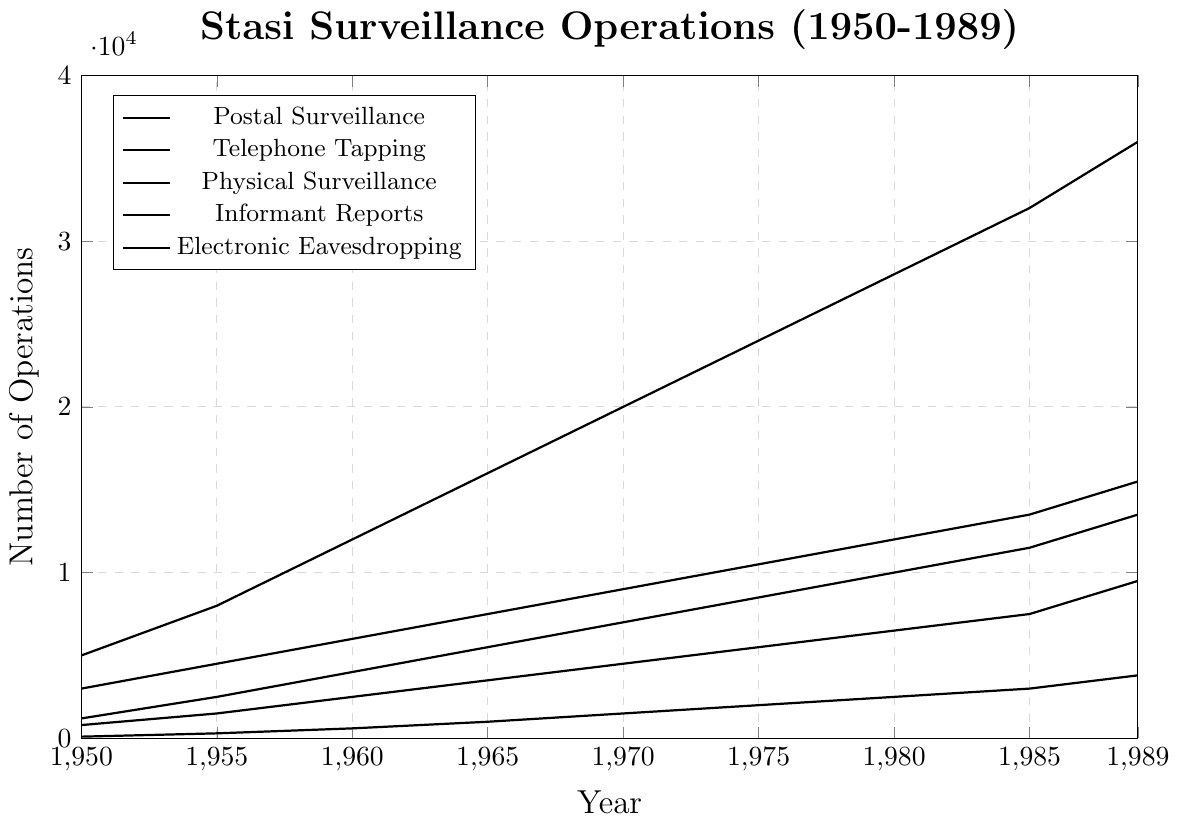Which surveillance type shows the highest number of operations in 1980? In the 1980 column of the chart, "Informant Reports" has the highest value at 28000 compared to the other categories.
Answer: Informant Reports How did the number of Physical Surveillance operations change from 1960 to 1970? In 1960, Physical Surveillance operations were at 6000, and in 1970 it increased to 9000. The change is calculated by subtracting 6000 from 9000.
Answer: Increased by 3000 Compare the trend of Postal Surveillance and Telephone Tapping from 1950 to 1989. Which one had a higher absolute increase? The Postal surveillance increased from 1200 to 13500, which is a change of 12300. Telephone Tapping increased from 800 to 9500, which is a change of 8700. Comparing these, Postal Surveillance had a higher absolute increase.
Answer: Postal Surveillance Which category shows the smallest increase over the entire period from 1950 to 1989? Electronic Eavesdropping increased from 100 to 3800 between 1950 and 1989. This is the smallest increase among all categories.
Answer: Electronic Eavesdropping Identify the year where Informant Reports crossed 30000. The data points show that in 1985, the number of Informant Reports reached 32000, which is the first year it crossed 30000.
Answer: 1985 In 1965, how many more Informant Reports were there compared to Postal Surveillance operations? In 1965, Informant Reports were at 16000 and Postal Surveillance at 5500. The difference is calculated by subtracting 5500 from 16000.
Answer: 10500 Which year did Telephone Tapping operations first surpass 7000? The data points show that in 1985, Telephone Tapping operations were at 7500, the first instance where it surpasses 7000.
Answer: 1985 Between Physical Surveillance and Electronic Eavesdropping, which had a relatively steeper increase from 1980 to 1989? From 1980 to 1989, Physical Surveillance increased from 12000 to 15500, a change of 3500. Electronic Eavesdropping increased from 2500 to 3800, a change of 1300. The absolute change is greater for Physical Surveillance.
Answer: Physical Surveillance 